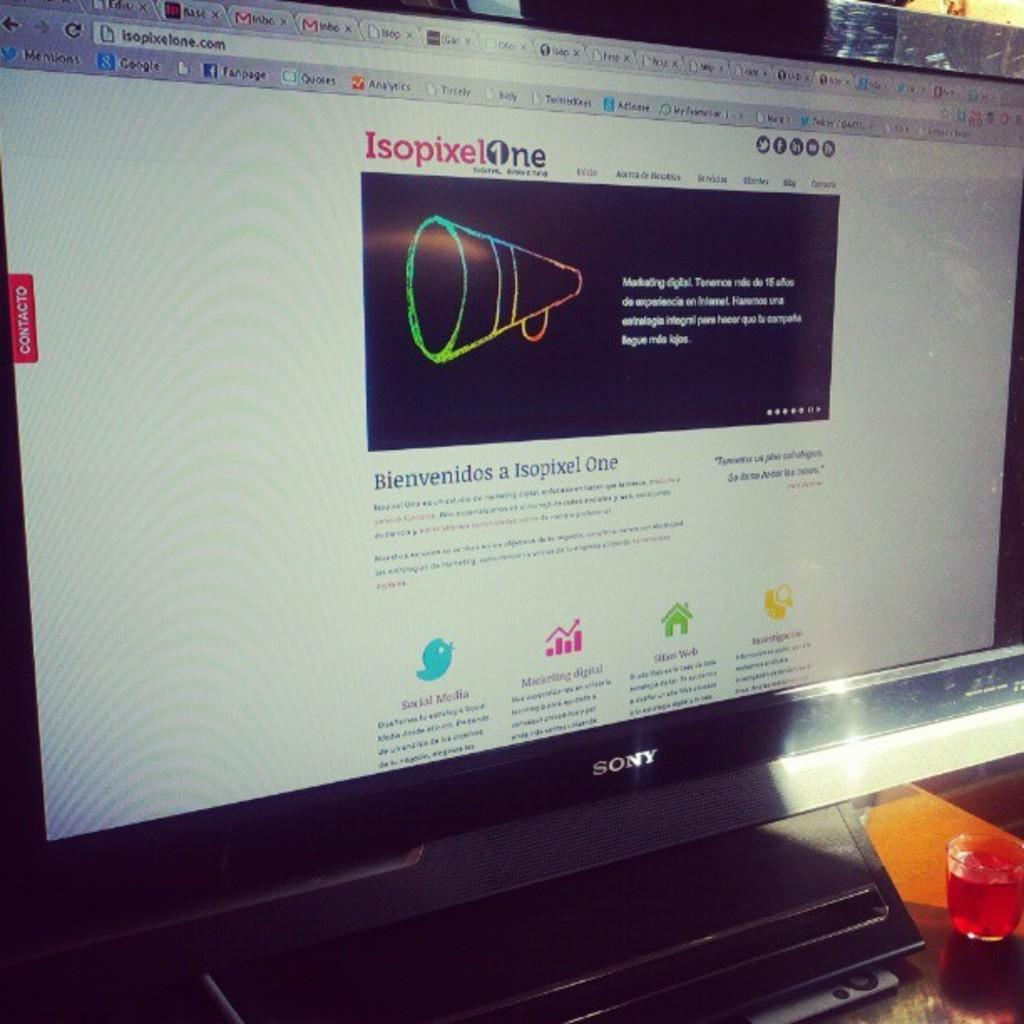<image>
Give a short and clear explanation of the subsequent image. an isopixel site that is on the computer 